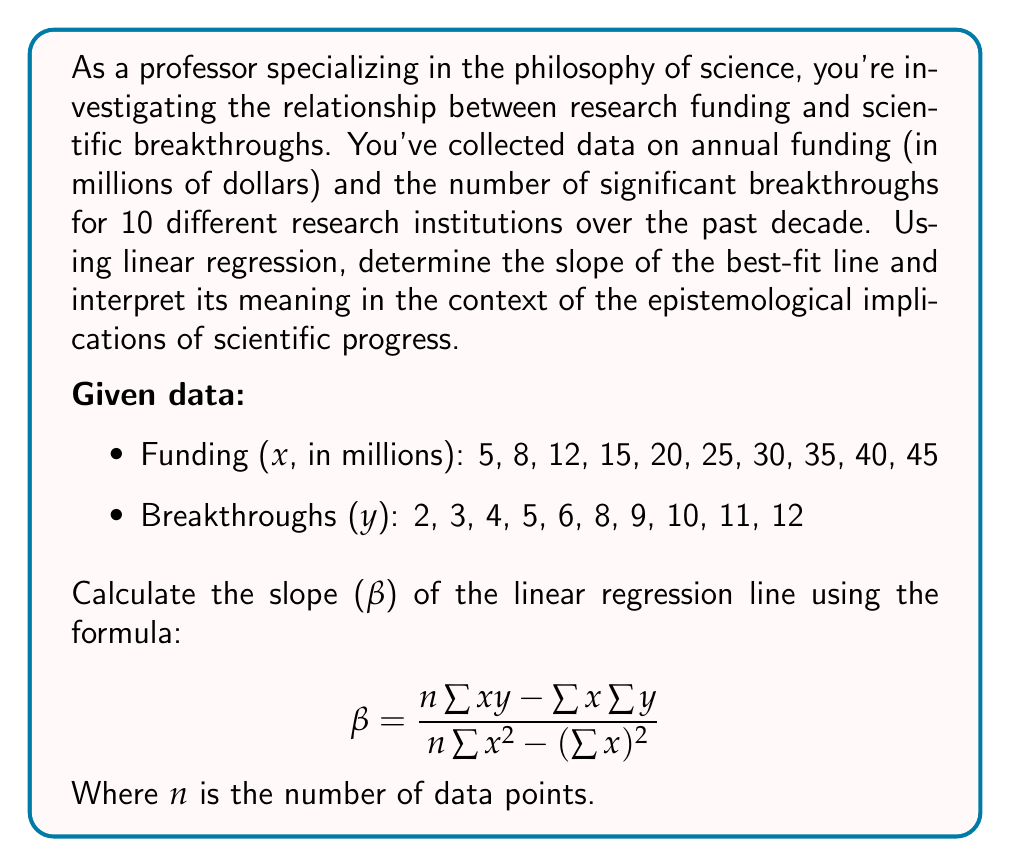Give your solution to this math problem. To solve this problem, we'll follow these steps:

1. Calculate the necessary sums: $\sum x$, $\sum y$, $\sum xy$, $\sum x^2$
2. Apply the formula for the slope (β)
3. Interpret the result

Step 1: Calculate the sums

$n = 10$ (number of data points)

$\sum x = 5 + 8 + 12 + 15 + 20 + 25 + 30 + 35 + 40 + 45 = 235$

$\sum y = 2 + 3 + 4 + 5 + 6 + 8 + 9 + 10 + 11 + 12 = 70$

$\sum xy = (5)(2) + (8)(3) + (12)(4) + (15)(5) + (20)(6) + (25)(8) + (30)(9) + (35)(10) + (40)(11) + (45)(12) = 1960$

$\sum x^2 = 5^2 + 8^2 + 12^2 + 15^2 + 20^2 + 25^2 + 30^2 + 35^2 + 40^2 + 45^2 = 7375$

Step 2: Apply the formula for the slope

$$ \beta = \frac{n\sum xy - \sum x \sum y}{n\sum x^2 - (\sum x)^2} $$

$$ \beta = \frac{10(1960) - (235)(70)}{10(7375) - (235)^2} $$

$$ \beta = \frac{19600 - 16450}{73750 - 55225} $$

$$ \beta = \frac{3150}{18525} $$

$$ \beta = 0.17 $$

Step 3: Interpret the result

The slope of the linear regression line is approximately 0.17. This means that, on average, for every additional million dollars of funding, we can expect an increase of 0.17 in the number of significant scientific breakthroughs.

From an epistemological perspective, this result suggests a positive correlation between funding and scientific progress. However, it's important to consider that this linear model simplifies a complex relationship and may not capture all factors influencing scientific breakthroughs. The philosophy of science would encourage us to critically examine this relationship, considering factors such as:

1. The diminishing returns of funding on breakthroughs
2. The role of serendipity in scientific discoveries
3. The potential bias in defining and measuring "significant breakthroughs"
4. The varying resource requirements across different scientific disciplines

This analysis provides a starting point for deeper philosophical inquiry into the nature of scientific progress and the factors that drive it.
Answer: The slope of the linear regression line is approximately 0.17, indicating that, on average, an increase of 1 million dollars in funding is associated with an increase of 0.17 in the number of significant scientific breakthroughs. 